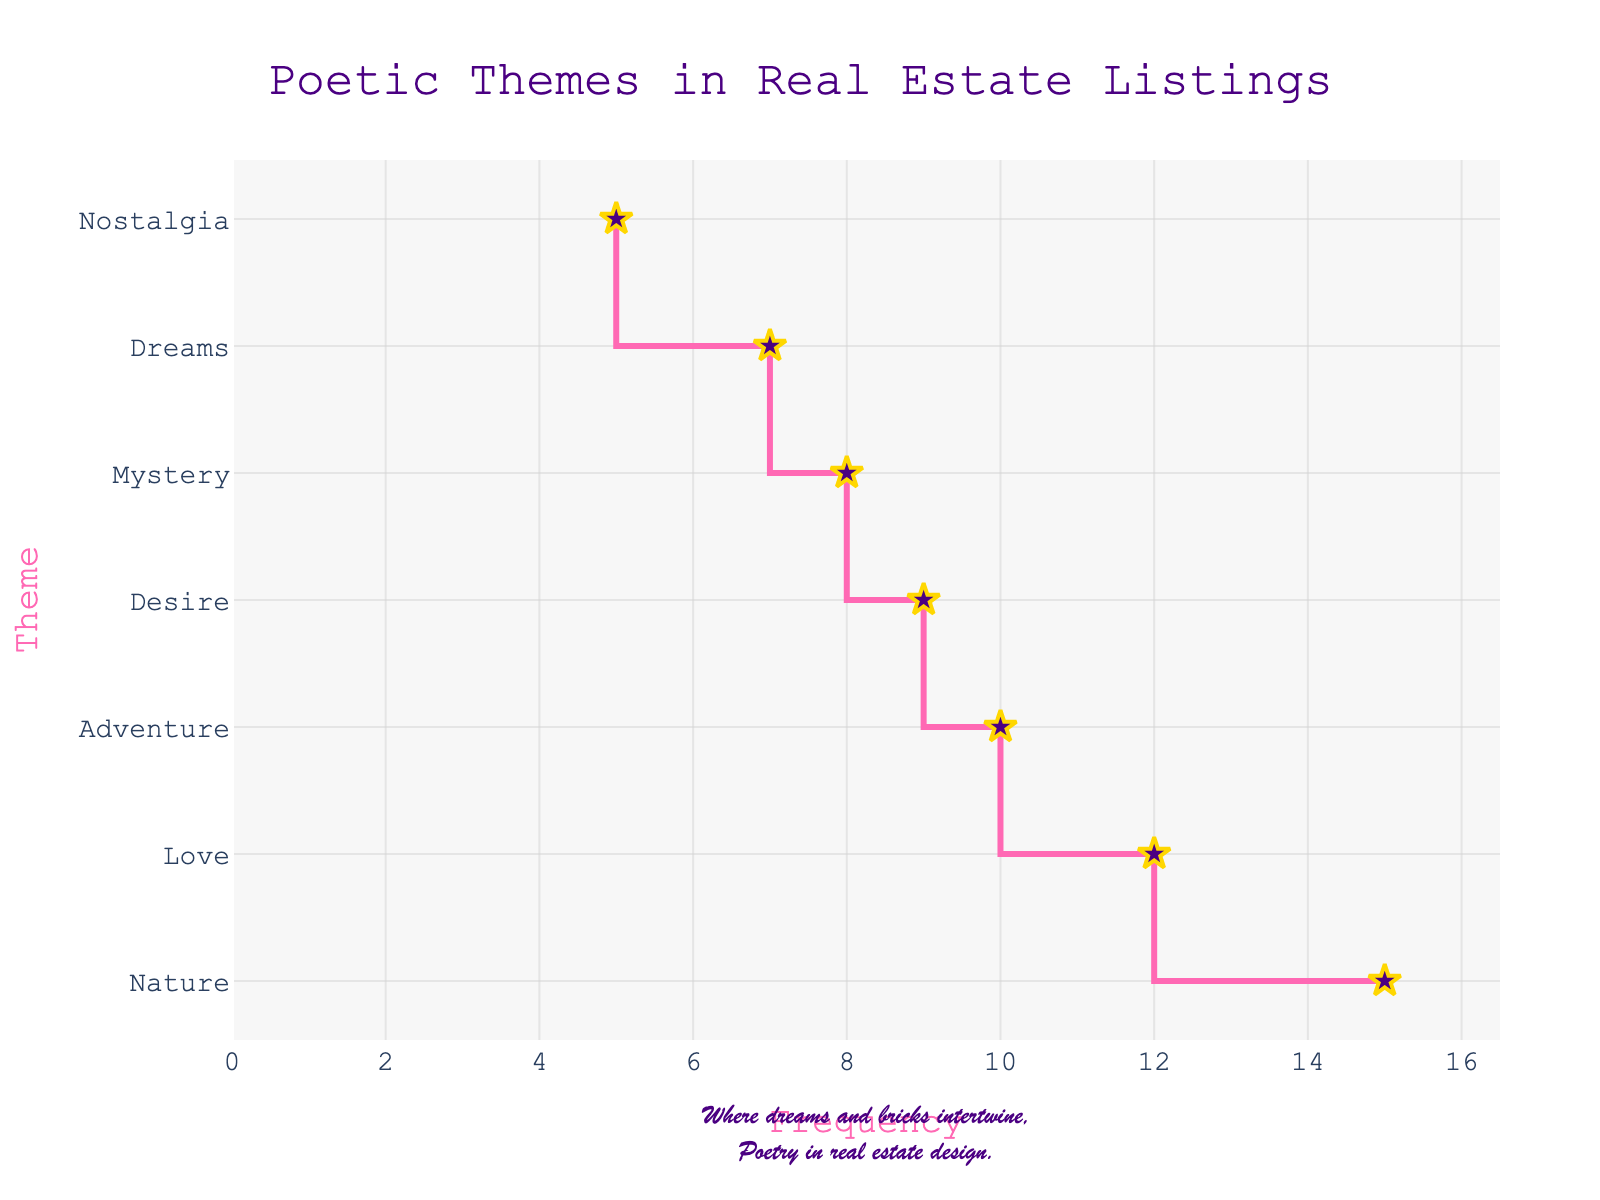What is the most frequently mentioned poetic theme in real estate listings? The figure shows a stair plot with different themes on the y-axis and their counts on the x-axis. By observing which theme has the highest count, we can determine the most frequently mentioned theme. In this case, "Nature" has the highest count of 15.
Answer: Nature How many themes have a frequency of at least 10 mentions? To answer this, look at the x-axis values and count the number of themes with a frequency of 10 or more. "Nature" (15), "Love" (12), and "Adventure" (10) are the themes that meet this criterion. There are three such themes.
Answer: 3 What's the combined frequency of the themes "Mystery" and "Dreams"? Find the counts of "Mystery" and "Dreams" from the plot, which are 8 and 7 respectively, then sum them up: 8 + 7 = 15.
Answer: 15 Which theme has the lowest frequency, and what is its count? The plot shows the themes and their counts. The theme with the lowest frequency is "Nostalgia," with a count of 5.
Answer: Nostalgia By how much does "Desire" exceed "Nostalgia" in frequency? Look at the counts for "Desire" and "Nostalgia" in the plot, which are 9 and 5 respectively. Subtract the count of "Nostalgia" from "Desire": 9 - 5 = 4.
Answer: 4 What is the median frequency of all the poetic themes? To find the median, list all the counts: 15, 12, 8, 10, 5, 7, 9. Sort these values: 5, 7, 8, 9, 10, 12, 15. The median is the middle value, which is 9.
Answer: 9 How many themes have a frequency less than the median frequency? The median frequency is found to be 9. Count the number of themes with a frequency less than 9: "Mystery" (8), "Nostalgia" (5), "Dreams" (7). There are three such themes.
Answer: 3 Which two themes have the closest frequencies, and what is the difference between them? Compare the frequencies of all themes to find the smallest difference. "Dreams" (7) and "Mystery" (8) have the closest frequencies. The difference is 1.
Answer: Dreams and Mystery Which theme represents the second-highest frequency, and what is its count? The highest frequency is for "Nature" (15). The next highest frequency is for "Love," which has a count of 12.
Answer: Love What is the range of the frequencies of the themes? The range is the difference between the highest and lowest counts. The highest count is 15 (Nature), and the lowest is 5 (Nostalgia). Calculate the range by subtracting the lowest from the highest: 15 - 5 = 10.
Answer: 10 